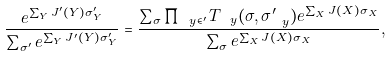Convert formula to latex. <formula><loc_0><loc_0><loc_500><loc_500>\frac { e ^ { \sum _ { Y } J ^ { \prime } ( Y ) \sigma ^ { \prime } _ { Y } } } { \sum _ { \sigma ^ { \prime } } e ^ { \sum _ { Y } J ^ { \prime } ( Y ) \sigma ^ { \prime } _ { Y } } } = \frac { \sum _ { \sigma } \prod _ { \ y \in \L ^ { \prime } } T _ { \ y } ( \sigma , \sigma ^ { \prime } _ { \ y } ) e ^ { \sum _ { X } J ( X ) \sigma _ { X } } } { \sum _ { \sigma } e ^ { \sum _ { X } J ( X ) \sigma _ { X } } } ,</formula> 